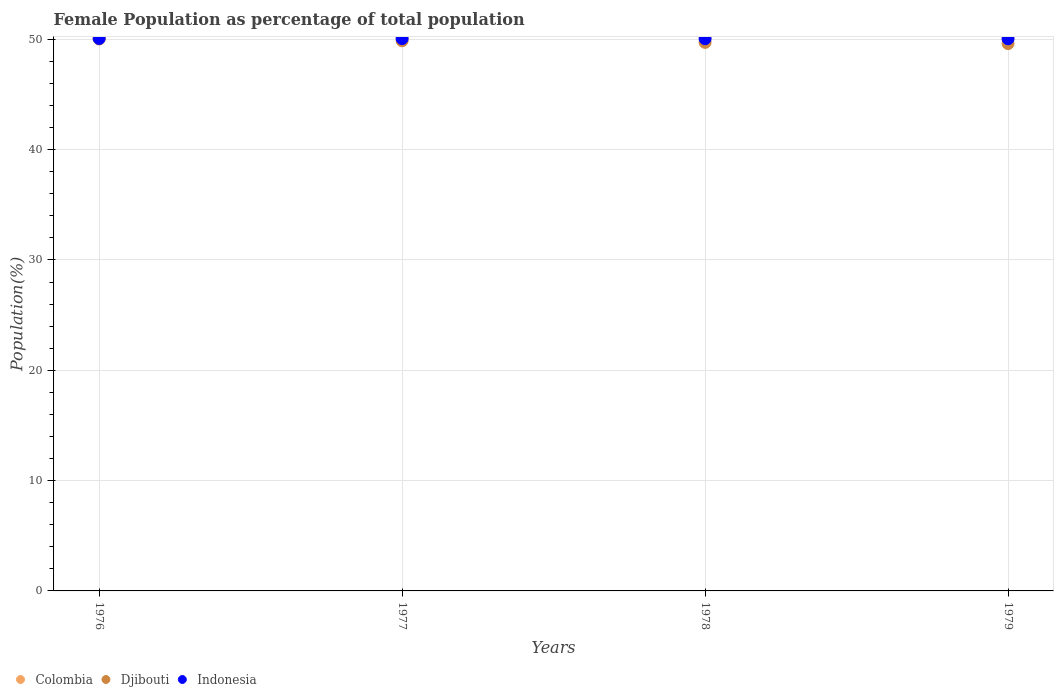How many different coloured dotlines are there?
Your response must be concise. 3. Is the number of dotlines equal to the number of legend labels?
Your answer should be compact. Yes. What is the female population in in Djibouti in 1978?
Provide a short and direct response. 49.73. Across all years, what is the maximum female population in in Indonesia?
Provide a succinct answer. 50.08. Across all years, what is the minimum female population in in Colombia?
Provide a succinct answer. 50.21. In which year was the female population in in Colombia maximum?
Offer a very short reply. 1976. In which year was the female population in in Djibouti minimum?
Your answer should be compact. 1979. What is the total female population in in Djibouti in the graph?
Ensure brevity in your answer.  199.25. What is the difference between the female population in in Indonesia in 1977 and that in 1979?
Offer a terse response. 0.02. What is the difference between the female population in in Djibouti in 1979 and the female population in in Indonesia in 1976?
Make the answer very short. -0.46. What is the average female population in in Djibouti per year?
Your response must be concise. 49.81. In the year 1977, what is the difference between the female population in in Djibouti and female population in in Indonesia?
Give a very brief answer. -0.2. What is the ratio of the female population in in Djibouti in 1976 to that in 1977?
Give a very brief answer. 1. What is the difference between the highest and the second highest female population in in Djibouti?
Provide a succinct answer. 0.16. What is the difference between the highest and the lowest female population in in Djibouti?
Offer a terse response. 0.42. Is the sum of the female population in in Indonesia in 1976 and 1978 greater than the maximum female population in in Djibouti across all years?
Offer a terse response. Yes. Is the female population in in Djibouti strictly greater than the female population in in Indonesia over the years?
Offer a very short reply. No. Is the female population in in Djibouti strictly less than the female population in in Indonesia over the years?
Make the answer very short. Yes. What is the difference between two consecutive major ticks on the Y-axis?
Your answer should be compact. 10. Are the values on the major ticks of Y-axis written in scientific E-notation?
Give a very brief answer. No. Does the graph contain grids?
Ensure brevity in your answer.  Yes. How many legend labels are there?
Your answer should be very brief. 3. How are the legend labels stacked?
Offer a terse response. Horizontal. What is the title of the graph?
Your answer should be very brief. Female Population as percentage of total population. Does "Malawi" appear as one of the legend labels in the graph?
Provide a short and direct response. No. What is the label or title of the Y-axis?
Offer a terse response. Population(%). What is the Population(%) of Colombia in 1976?
Keep it short and to the point. 50.22. What is the Population(%) of Djibouti in 1976?
Offer a very short reply. 50.03. What is the Population(%) of Indonesia in 1976?
Make the answer very short. 50.08. What is the Population(%) of Colombia in 1977?
Your response must be concise. 50.22. What is the Population(%) of Djibouti in 1977?
Keep it short and to the point. 49.87. What is the Population(%) in Indonesia in 1977?
Ensure brevity in your answer.  50.07. What is the Population(%) in Colombia in 1978?
Your answer should be compact. 50.21. What is the Population(%) in Djibouti in 1978?
Give a very brief answer. 49.73. What is the Population(%) in Indonesia in 1978?
Your answer should be compact. 50.06. What is the Population(%) of Colombia in 1979?
Ensure brevity in your answer.  50.21. What is the Population(%) in Djibouti in 1979?
Keep it short and to the point. 49.62. What is the Population(%) in Indonesia in 1979?
Your answer should be compact. 50.05. Across all years, what is the maximum Population(%) in Colombia?
Give a very brief answer. 50.22. Across all years, what is the maximum Population(%) of Djibouti?
Provide a short and direct response. 50.03. Across all years, what is the maximum Population(%) of Indonesia?
Keep it short and to the point. 50.08. Across all years, what is the minimum Population(%) of Colombia?
Your response must be concise. 50.21. Across all years, what is the minimum Population(%) in Djibouti?
Your response must be concise. 49.62. Across all years, what is the minimum Population(%) in Indonesia?
Give a very brief answer. 50.05. What is the total Population(%) of Colombia in the graph?
Make the answer very short. 200.86. What is the total Population(%) of Djibouti in the graph?
Your answer should be very brief. 199.25. What is the total Population(%) in Indonesia in the graph?
Offer a terse response. 200.26. What is the difference between the Population(%) of Colombia in 1976 and that in 1977?
Provide a short and direct response. 0.01. What is the difference between the Population(%) in Djibouti in 1976 and that in 1977?
Your answer should be very brief. 0.16. What is the difference between the Population(%) of Indonesia in 1976 and that in 1977?
Ensure brevity in your answer.  0.01. What is the difference between the Population(%) in Colombia in 1976 and that in 1978?
Make the answer very short. 0.01. What is the difference between the Population(%) of Djibouti in 1976 and that in 1978?
Ensure brevity in your answer.  0.31. What is the difference between the Population(%) of Indonesia in 1976 and that in 1978?
Your answer should be compact. 0.02. What is the difference between the Population(%) of Colombia in 1976 and that in 1979?
Offer a very short reply. 0.01. What is the difference between the Population(%) of Djibouti in 1976 and that in 1979?
Make the answer very short. 0.42. What is the difference between the Population(%) of Indonesia in 1976 and that in 1979?
Make the answer very short. 0.03. What is the difference between the Population(%) in Colombia in 1977 and that in 1978?
Your answer should be compact. 0.01. What is the difference between the Population(%) of Djibouti in 1977 and that in 1978?
Your response must be concise. 0.15. What is the difference between the Population(%) in Indonesia in 1977 and that in 1978?
Offer a very short reply. 0.01. What is the difference between the Population(%) of Colombia in 1977 and that in 1979?
Make the answer very short. 0.01. What is the difference between the Population(%) of Djibouti in 1977 and that in 1979?
Provide a succinct answer. 0.26. What is the difference between the Population(%) of Indonesia in 1977 and that in 1979?
Your answer should be very brief. 0.02. What is the difference between the Population(%) in Colombia in 1978 and that in 1979?
Your answer should be very brief. 0. What is the difference between the Population(%) of Djibouti in 1978 and that in 1979?
Offer a very short reply. 0.11. What is the difference between the Population(%) of Indonesia in 1978 and that in 1979?
Provide a short and direct response. 0.01. What is the difference between the Population(%) in Colombia in 1976 and the Population(%) in Djibouti in 1977?
Give a very brief answer. 0.35. What is the difference between the Population(%) in Colombia in 1976 and the Population(%) in Indonesia in 1977?
Provide a succinct answer. 0.15. What is the difference between the Population(%) in Djibouti in 1976 and the Population(%) in Indonesia in 1977?
Ensure brevity in your answer.  -0.04. What is the difference between the Population(%) in Colombia in 1976 and the Population(%) in Djibouti in 1978?
Give a very brief answer. 0.5. What is the difference between the Population(%) of Colombia in 1976 and the Population(%) of Indonesia in 1978?
Offer a terse response. 0.16. What is the difference between the Population(%) in Djibouti in 1976 and the Population(%) in Indonesia in 1978?
Your response must be concise. -0.03. What is the difference between the Population(%) in Colombia in 1976 and the Population(%) in Djibouti in 1979?
Make the answer very short. 0.61. What is the difference between the Population(%) in Colombia in 1976 and the Population(%) in Indonesia in 1979?
Give a very brief answer. 0.17. What is the difference between the Population(%) of Djibouti in 1976 and the Population(%) of Indonesia in 1979?
Give a very brief answer. -0.02. What is the difference between the Population(%) in Colombia in 1977 and the Population(%) in Djibouti in 1978?
Make the answer very short. 0.49. What is the difference between the Population(%) in Colombia in 1977 and the Population(%) in Indonesia in 1978?
Your answer should be very brief. 0.16. What is the difference between the Population(%) in Djibouti in 1977 and the Population(%) in Indonesia in 1978?
Ensure brevity in your answer.  -0.19. What is the difference between the Population(%) of Colombia in 1977 and the Population(%) of Djibouti in 1979?
Your answer should be compact. 0.6. What is the difference between the Population(%) in Colombia in 1977 and the Population(%) in Indonesia in 1979?
Your answer should be compact. 0.17. What is the difference between the Population(%) of Djibouti in 1977 and the Population(%) of Indonesia in 1979?
Offer a very short reply. -0.18. What is the difference between the Population(%) of Colombia in 1978 and the Population(%) of Djibouti in 1979?
Provide a succinct answer. 0.59. What is the difference between the Population(%) of Colombia in 1978 and the Population(%) of Indonesia in 1979?
Your answer should be very brief. 0.16. What is the difference between the Population(%) of Djibouti in 1978 and the Population(%) of Indonesia in 1979?
Give a very brief answer. -0.32. What is the average Population(%) in Colombia per year?
Provide a succinct answer. 50.21. What is the average Population(%) of Djibouti per year?
Ensure brevity in your answer.  49.81. What is the average Population(%) of Indonesia per year?
Offer a very short reply. 50.07. In the year 1976, what is the difference between the Population(%) of Colombia and Population(%) of Djibouti?
Keep it short and to the point. 0.19. In the year 1976, what is the difference between the Population(%) of Colombia and Population(%) of Indonesia?
Give a very brief answer. 0.14. In the year 1976, what is the difference between the Population(%) in Djibouti and Population(%) in Indonesia?
Make the answer very short. -0.05. In the year 1977, what is the difference between the Population(%) in Colombia and Population(%) in Djibouti?
Keep it short and to the point. 0.34. In the year 1977, what is the difference between the Population(%) of Colombia and Population(%) of Indonesia?
Your response must be concise. 0.15. In the year 1977, what is the difference between the Population(%) of Djibouti and Population(%) of Indonesia?
Provide a short and direct response. -0.2. In the year 1978, what is the difference between the Population(%) in Colombia and Population(%) in Djibouti?
Keep it short and to the point. 0.48. In the year 1978, what is the difference between the Population(%) in Colombia and Population(%) in Indonesia?
Offer a terse response. 0.15. In the year 1978, what is the difference between the Population(%) in Djibouti and Population(%) in Indonesia?
Provide a succinct answer. -0.33. In the year 1979, what is the difference between the Population(%) in Colombia and Population(%) in Djibouti?
Give a very brief answer. 0.59. In the year 1979, what is the difference between the Population(%) of Colombia and Population(%) of Indonesia?
Offer a very short reply. 0.16. In the year 1979, what is the difference between the Population(%) of Djibouti and Population(%) of Indonesia?
Your response must be concise. -0.43. What is the ratio of the Population(%) of Djibouti in 1976 to that in 1978?
Your response must be concise. 1.01. What is the ratio of the Population(%) of Indonesia in 1976 to that in 1978?
Give a very brief answer. 1. What is the ratio of the Population(%) of Colombia in 1976 to that in 1979?
Offer a terse response. 1. What is the ratio of the Population(%) of Djibouti in 1976 to that in 1979?
Provide a short and direct response. 1.01. What is the ratio of the Population(%) in Indonesia in 1976 to that in 1979?
Provide a succinct answer. 1. What is the ratio of the Population(%) of Colombia in 1977 to that in 1978?
Give a very brief answer. 1. What is the ratio of the Population(%) of Djibouti in 1977 to that in 1978?
Provide a short and direct response. 1. What is the ratio of the Population(%) in Indonesia in 1977 to that in 1979?
Your answer should be compact. 1. What is the ratio of the Population(%) of Colombia in 1978 to that in 1979?
Your answer should be very brief. 1. What is the difference between the highest and the second highest Population(%) of Colombia?
Offer a terse response. 0.01. What is the difference between the highest and the second highest Population(%) in Djibouti?
Your response must be concise. 0.16. What is the difference between the highest and the second highest Population(%) in Indonesia?
Offer a very short reply. 0.01. What is the difference between the highest and the lowest Population(%) of Colombia?
Keep it short and to the point. 0.01. What is the difference between the highest and the lowest Population(%) of Djibouti?
Provide a succinct answer. 0.42. What is the difference between the highest and the lowest Population(%) in Indonesia?
Keep it short and to the point. 0.03. 